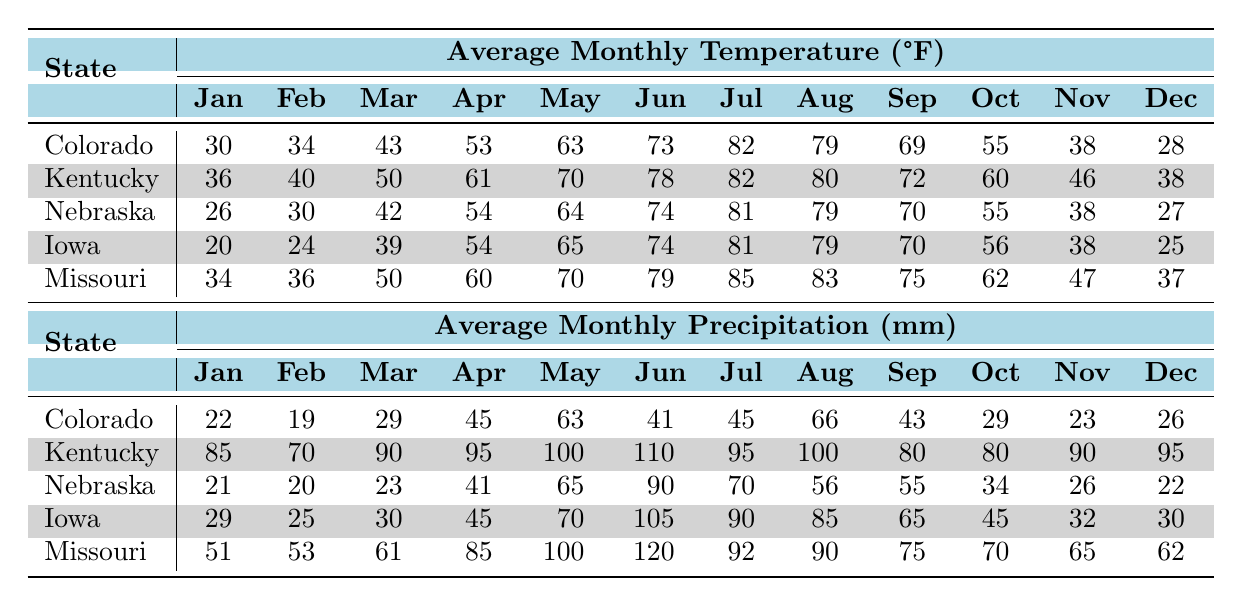What is the average temperature in July for Colorado? We look at the average monthly temperature data for Colorado and find the value for July, which is 82°F.
Answer: 82°F Which state has the highest average precipitation in January? We review the average monthly precipitation data for January across all listed states and see that Kentucky has the highest value at 85 mm.
Answer: Kentucky What is the difference in average temperatures between Nebraska in May and Missouri in May? We find Nebraska's average temperature for May, which is 64°F, and Missouri's average temperature for May, which is 70°F. The difference is 70 - 64 = 6°F.
Answer: 6°F Is the average precipitation in June for Iowa greater than that for Colorado? The average precipitation for Iowa in June is 105 mm, while for Colorado, it is 41 mm. Since 105 mm is greater than 41 mm, the statement is true.
Answer: Yes What is the average precipitation across all states in August? First, we find the average precipitation for August from each state: Colorado 66 mm, Kentucky 100 mm, Nebraska 56 mm, Iowa 85 mm, and Missouri 90 mm. The total is 66 + 100 + 56 + 85 + 90 = 397 mm. We divide by the number of states, which is 5, resulting in an average of 397/5 = 79.4 mm.
Answer: 79.4 mm Which month has the lowest average temperature in Iowa? Looking at the average monthly temperatures for Iowa, January has the lowest recorded temperature of 20°F.
Answer: January Which state has the warmest average temperature in December? We check the average temperatures in December for all states: Colorado 28°F, Kentucky 38°F, Nebraska 27°F, Iowa 25°F, and Missouri 37°F. Kentucky has the highest at 38°F.
Answer: Kentucky What is the total average precipitation for Missouri over the year? We sum the monthly precipitation values for Missouri: 51 + 53 + 61 + 85 + 100 + 120 + 92 + 90 + 75 + 70 + 65 + 62 = 999 mm.
Answer: 999 mm 